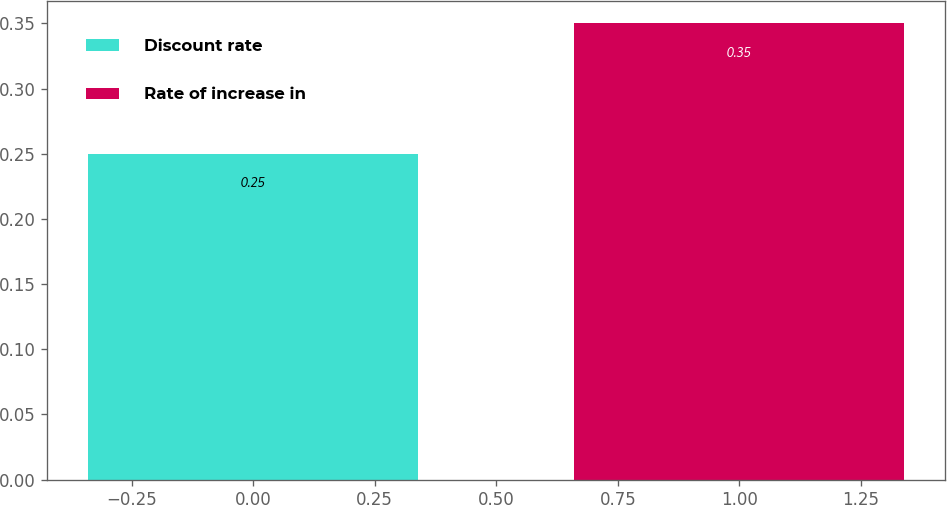Convert chart to OTSL. <chart><loc_0><loc_0><loc_500><loc_500><bar_chart><fcel>Discount rate<fcel>Rate of increase in<nl><fcel>0.25<fcel>0.35<nl></chart> 